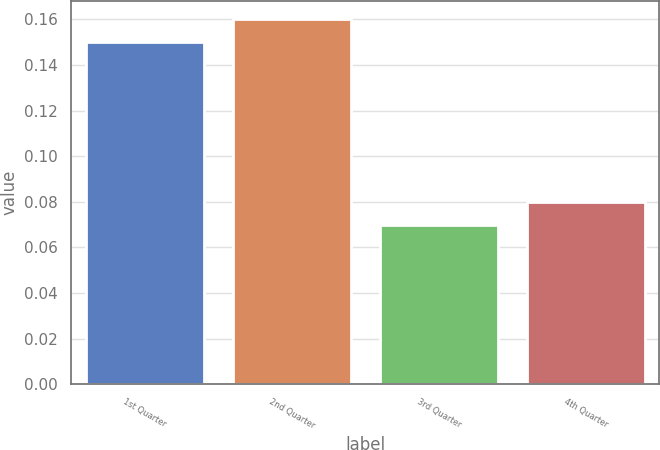Convert chart. <chart><loc_0><loc_0><loc_500><loc_500><bar_chart><fcel>1st Quarter<fcel>2nd Quarter<fcel>3rd Quarter<fcel>4th Quarter<nl><fcel>0.15<fcel>0.16<fcel>0.07<fcel>0.08<nl></chart> 